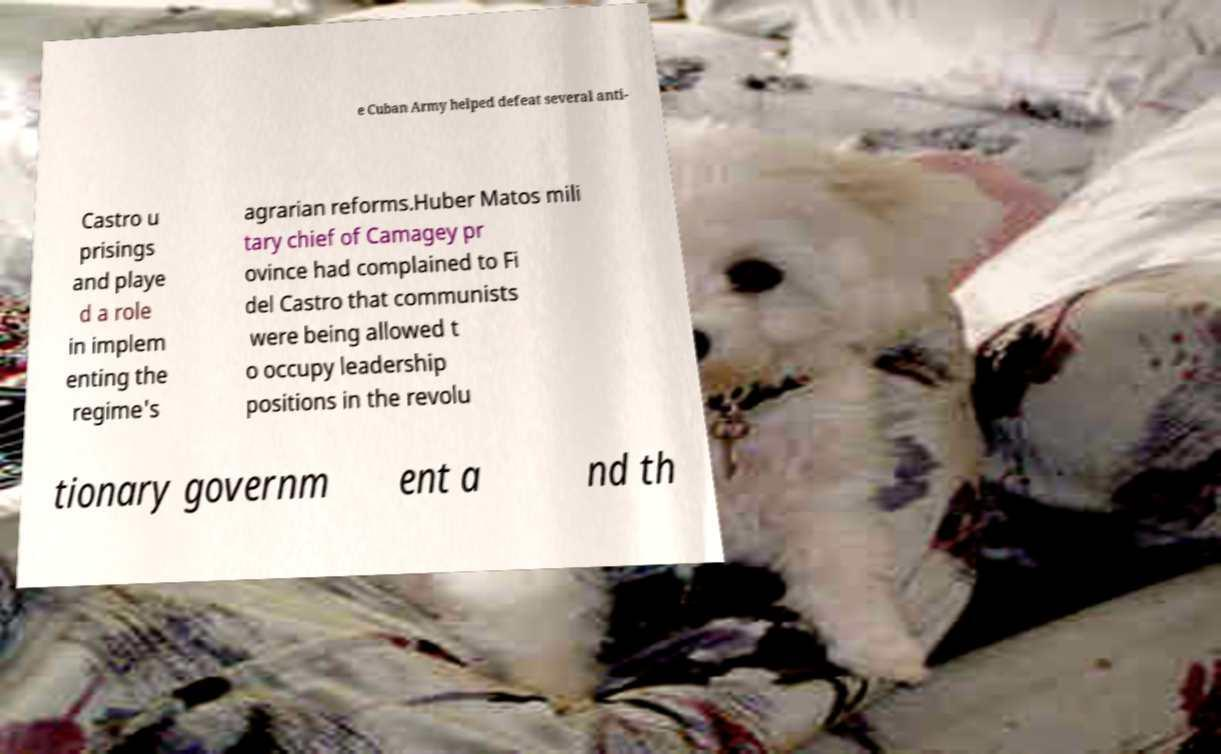There's text embedded in this image that I need extracted. Can you transcribe it verbatim? e Cuban Army helped defeat several anti- Castro u prisings and playe d a role in implem enting the regime's agrarian reforms.Huber Matos mili tary chief of Camagey pr ovince had complained to Fi del Castro that communists were being allowed t o occupy leadership positions in the revolu tionary governm ent a nd th 